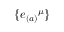<formula> <loc_0><loc_0><loc_500><loc_500>\{ { e _ { ( a ) } } ^ { \mu } \}</formula> 